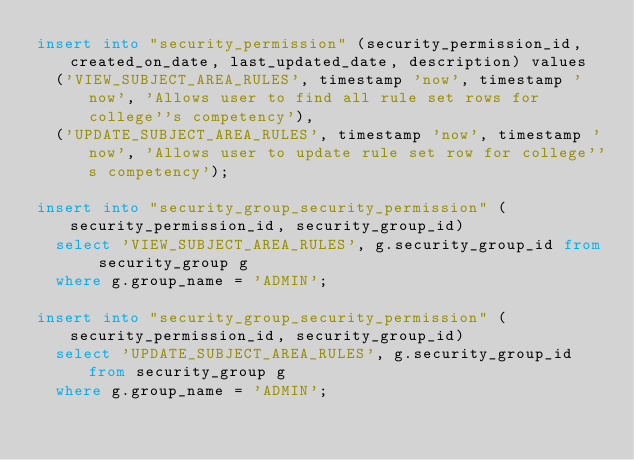<code> <loc_0><loc_0><loc_500><loc_500><_SQL_>insert into "security_permission" (security_permission_id, created_on_date, last_updated_date, description) values
  ('VIEW_SUBJECT_AREA_RULES', timestamp 'now', timestamp 'now', 'Allows user to find all rule set rows for college''s competency'),
  ('UPDATE_SUBJECT_AREA_RULES', timestamp 'now', timestamp 'now', 'Allows user to update rule set row for college''s competency');

insert into "security_group_security_permission" (security_permission_id, security_group_id)
  select 'VIEW_SUBJECT_AREA_RULES', g.security_group_id from security_group g
  where g.group_name = 'ADMIN';

insert into "security_group_security_permission" (security_permission_id, security_group_id)
  select 'UPDATE_SUBJECT_AREA_RULES', g.security_group_id from security_group g
  where g.group_name = 'ADMIN';
</code> 